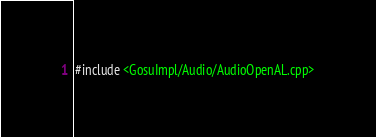Convert code to text. <code><loc_0><loc_0><loc_500><loc_500><_ObjectiveC_>#include <GosuImpl/Audio/AudioOpenAL.cpp>
</code> 